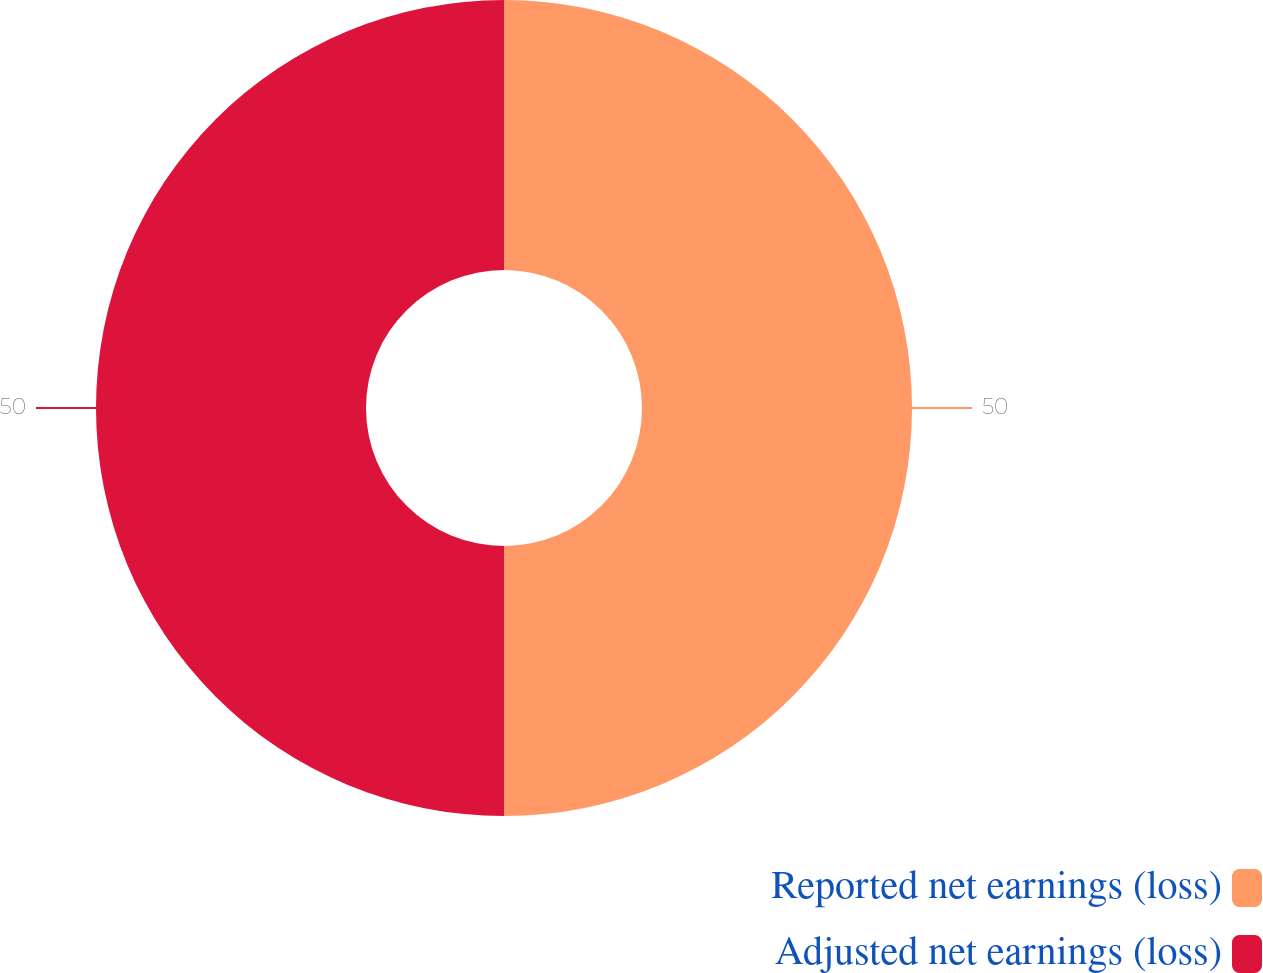Convert chart to OTSL. <chart><loc_0><loc_0><loc_500><loc_500><pie_chart><fcel>Reported net earnings (loss)<fcel>Adjusted net earnings (loss)<nl><fcel>50.0%<fcel>50.0%<nl></chart> 